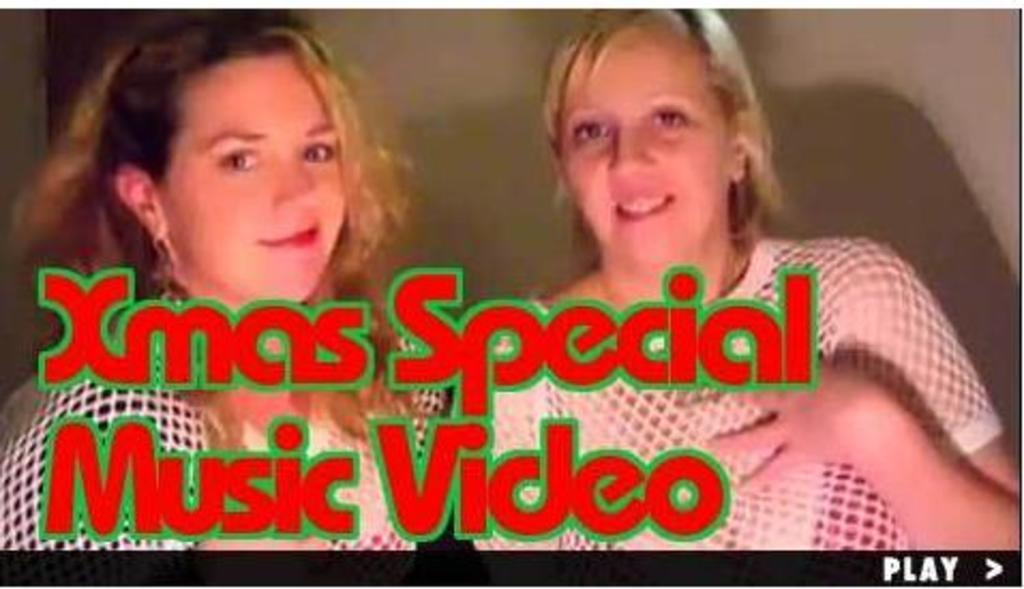How many people are in the image? There are two women in the image. What can be seen in the background of the image? There is a wall in the background of the image. Is there any text present in the image? Yes, there is text visible on the image. How many stars can be seen in the image? There are no stars visible in the image. 